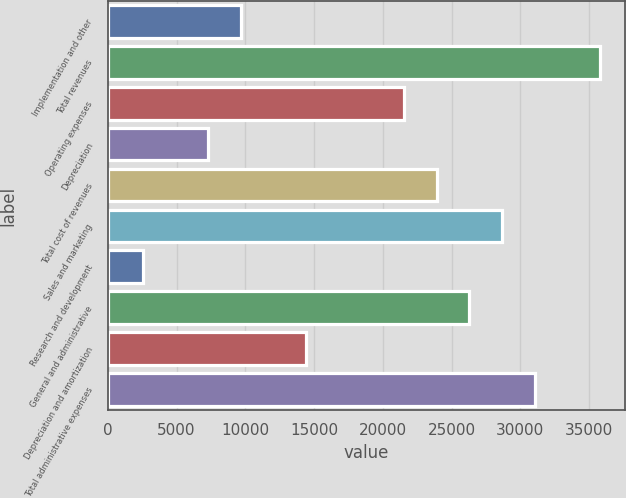<chart> <loc_0><loc_0><loc_500><loc_500><bar_chart><fcel>Implementation and other<fcel>Total revenues<fcel>Operating expenses<fcel>Depreciation<fcel>Total cost of revenues<fcel>Sales and marketing<fcel>Research and development<fcel>General and administrative<fcel>Depreciation and amortization<fcel>Total administrative expenses<nl><fcel>9667<fcel>35786.5<fcel>21539.5<fcel>7292.5<fcel>23914<fcel>28663<fcel>2543.5<fcel>26288.5<fcel>14416<fcel>31037.5<nl></chart> 